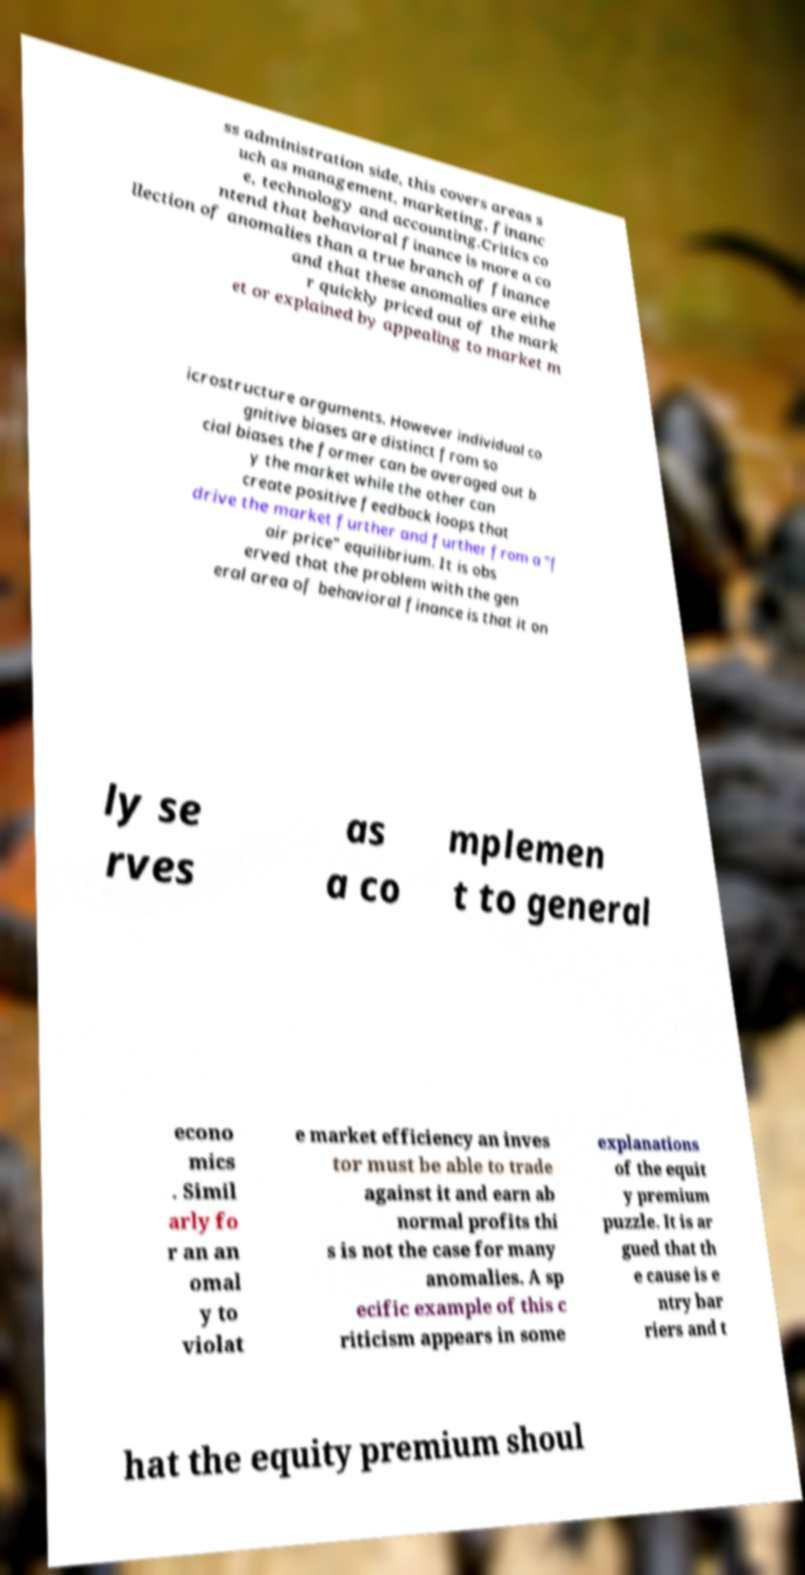Can you read and provide the text displayed in the image?This photo seems to have some interesting text. Can you extract and type it out for me? ss administration side, this covers areas s uch as management, marketing, financ e, technology and accounting.Critics co ntend that behavioral finance is more a co llection of anomalies than a true branch of finance and that these anomalies are eithe r quickly priced out of the mark et or explained by appealing to market m icrostructure arguments. However individual co gnitive biases are distinct from so cial biases the former can be averaged out b y the market while the other can create positive feedback loops that drive the market further and further from a "f air price" equilibrium. It is obs erved that the problem with the gen eral area of behavioral finance is that it on ly se rves as a co mplemen t to general econo mics . Simil arly fo r an an omal y to violat e market efficiency an inves tor must be able to trade against it and earn ab normal profits thi s is not the case for many anomalies. A sp ecific example of this c riticism appears in some explanations of the equit y premium puzzle. It is ar gued that th e cause is e ntry bar riers and t hat the equity premium shoul 